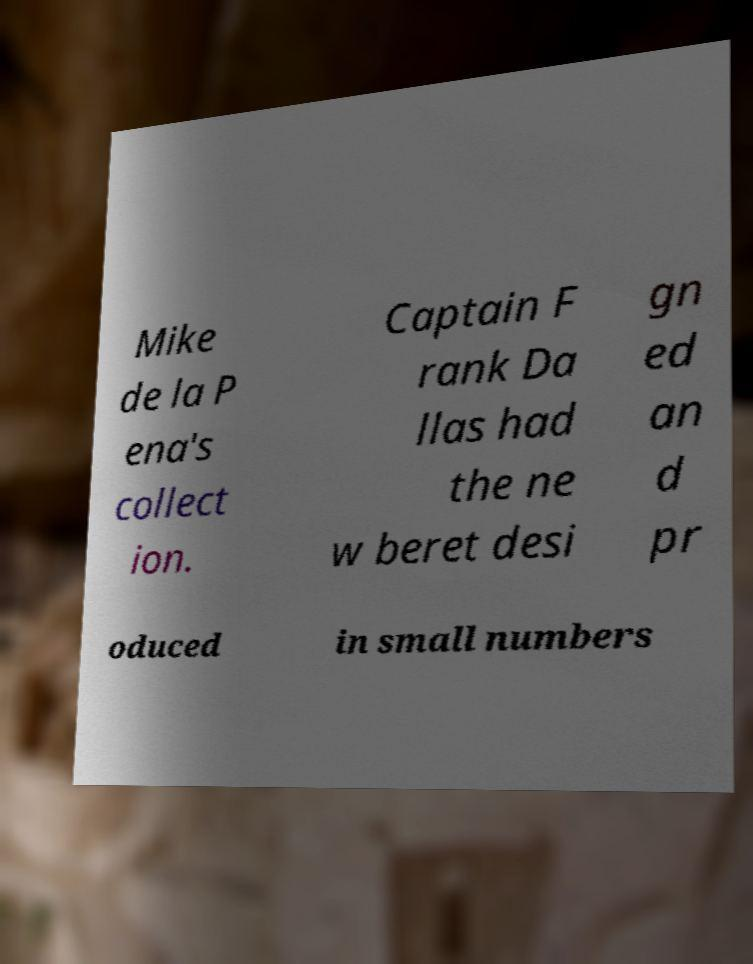Please identify and transcribe the text found in this image. Mike de la P ena's collect ion. Captain F rank Da llas had the ne w beret desi gn ed an d pr oduced in small numbers 